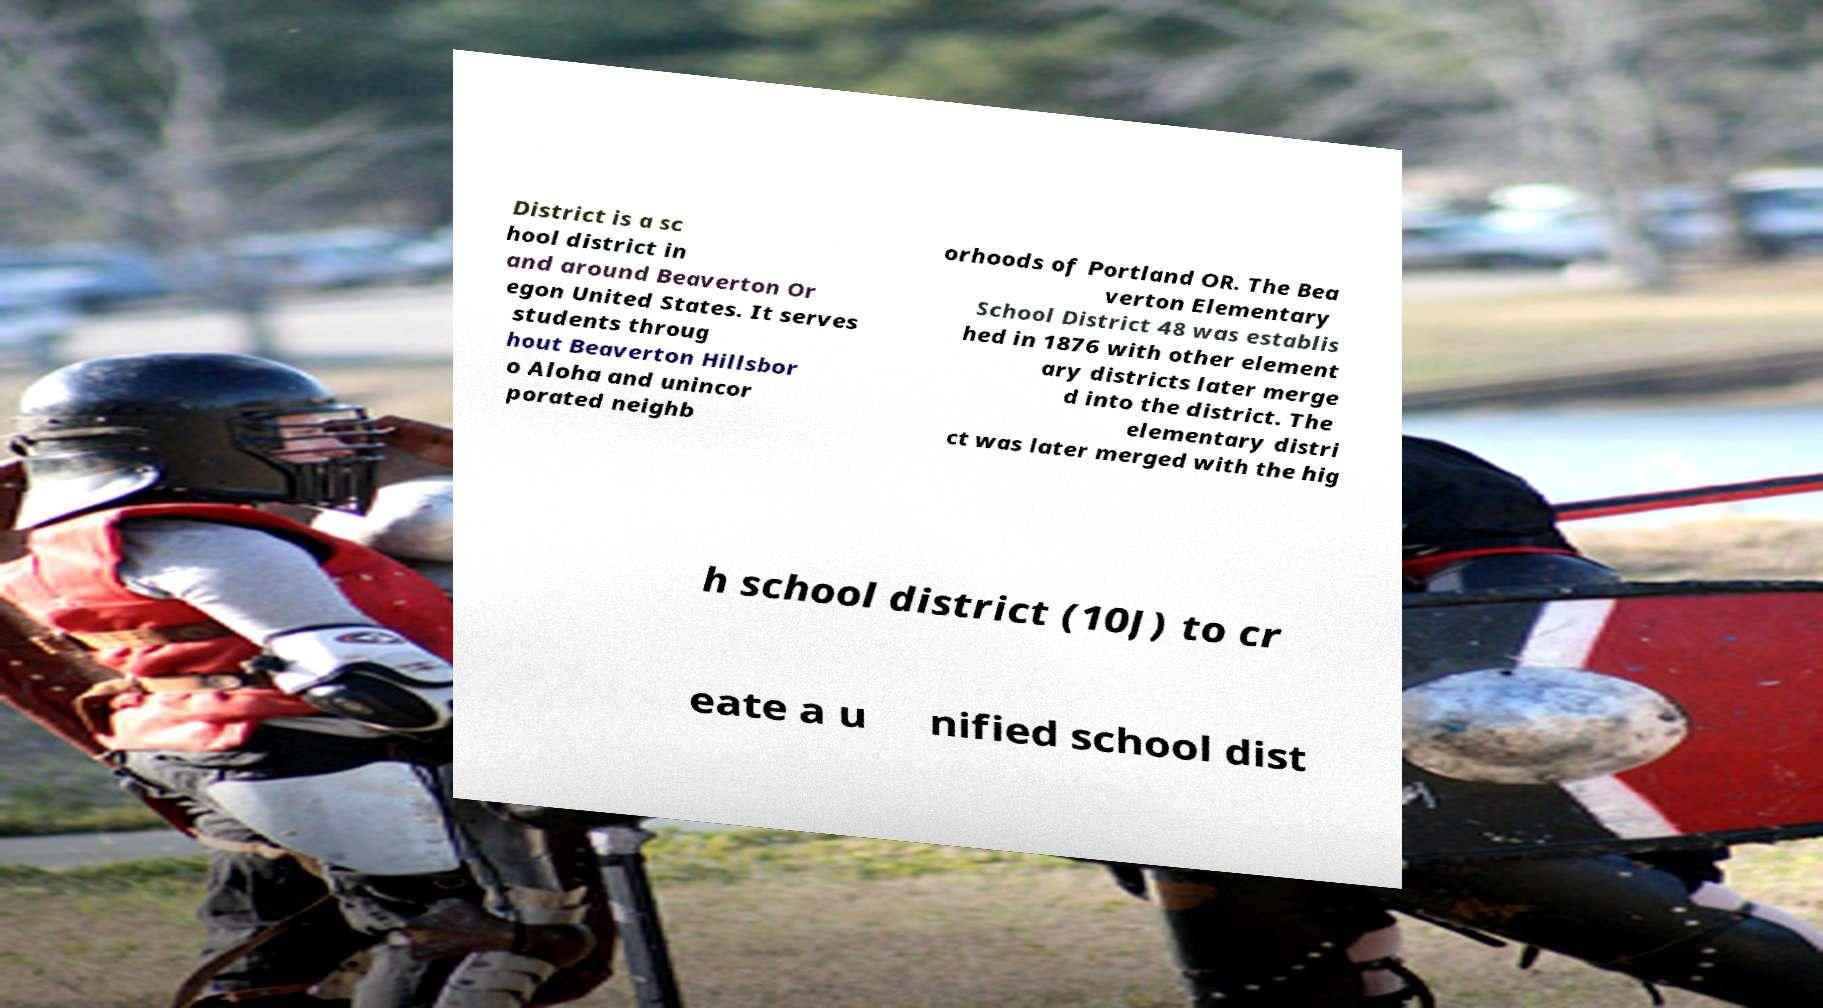For documentation purposes, I need the text within this image transcribed. Could you provide that? District is a sc hool district in and around Beaverton Or egon United States. It serves students throug hout Beaverton Hillsbor o Aloha and unincor porated neighb orhoods of Portland OR. The Bea verton Elementary School District 48 was establis hed in 1876 with other element ary districts later merge d into the district. The elementary distri ct was later merged with the hig h school district (10J) to cr eate a u nified school dist 